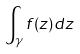<formula> <loc_0><loc_0><loc_500><loc_500>\int _ { \gamma } f ( z ) d z</formula> 